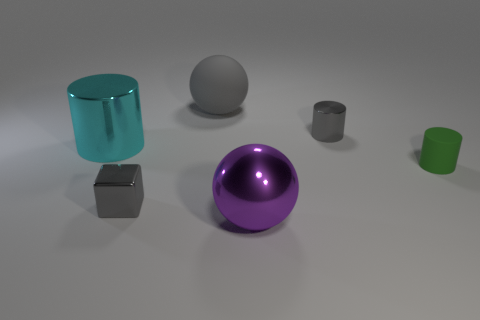Add 4 cylinders. How many objects exist? 10 Subtract all cyan blocks. Subtract all gray cylinders. How many blocks are left? 1 Subtract all cubes. How many objects are left? 5 Subtract 0 yellow cylinders. How many objects are left? 6 Subtract all tiny yellow things. Subtract all big purple things. How many objects are left? 5 Add 4 cyan metal cylinders. How many cyan metal cylinders are left? 5 Add 1 large rubber things. How many large rubber things exist? 2 